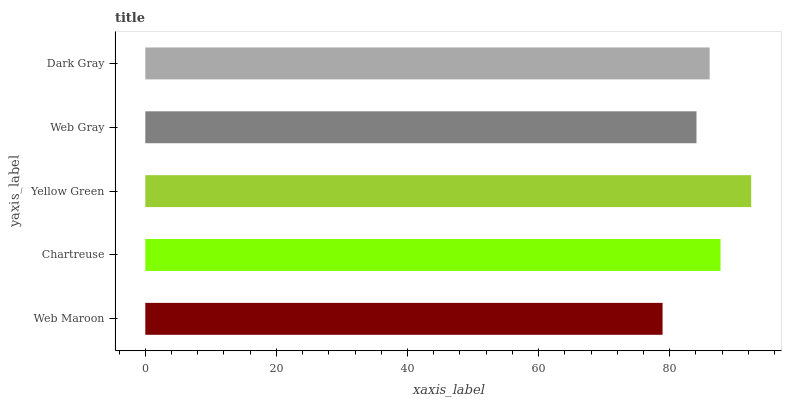Is Web Maroon the minimum?
Answer yes or no. Yes. Is Yellow Green the maximum?
Answer yes or no. Yes. Is Chartreuse the minimum?
Answer yes or no. No. Is Chartreuse the maximum?
Answer yes or no. No. Is Chartreuse greater than Web Maroon?
Answer yes or no. Yes. Is Web Maroon less than Chartreuse?
Answer yes or no. Yes. Is Web Maroon greater than Chartreuse?
Answer yes or no. No. Is Chartreuse less than Web Maroon?
Answer yes or no. No. Is Dark Gray the high median?
Answer yes or no. Yes. Is Dark Gray the low median?
Answer yes or no. Yes. Is Web Maroon the high median?
Answer yes or no. No. Is Web Gray the low median?
Answer yes or no. No. 